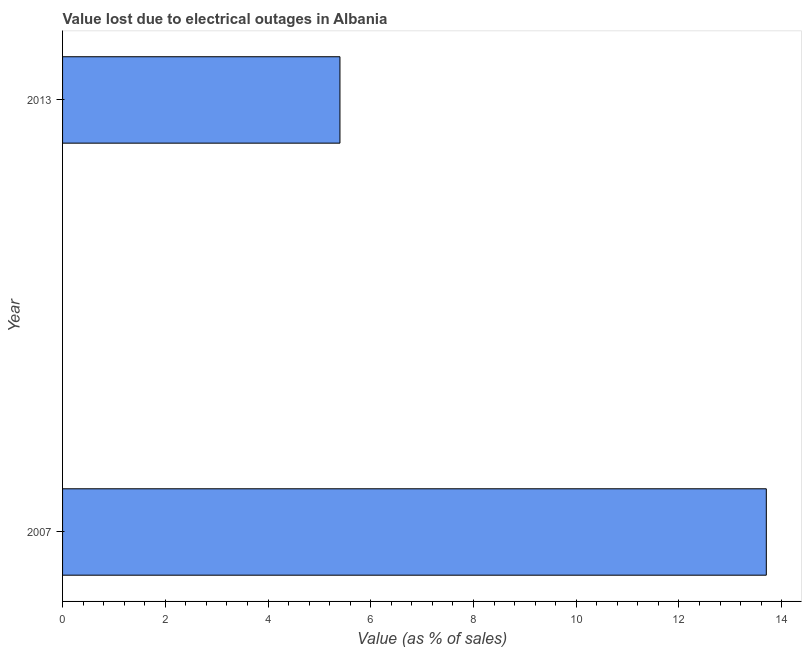Does the graph contain grids?
Offer a terse response. No. What is the title of the graph?
Make the answer very short. Value lost due to electrical outages in Albania. What is the label or title of the X-axis?
Provide a succinct answer. Value (as % of sales). What is the label or title of the Y-axis?
Your answer should be very brief. Year. Across all years, what is the minimum value lost due to electrical outages?
Provide a short and direct response. 5.4. In which year was the value lost due to electrical outages maximum?
Offer a terse response. 2007. In which year was the value lost due to electrical outages minimum?
Provide a short and direct response. 2013. What is the difference between the value lost due to electrical outages in 2007 and 2013?
Keep it short and to the point. 8.3. What is the average value lost due to electrical outages per year?
Make the answer very short. 9.55. What is the median value lost due to electrical outages?
Keep it short and to the point. 9.55. Do a majority of the years between 2007 and 2013 (inclusive) have value lost due to electrical outages greater than 6.4 %?
Your response must be concise. No. What is the ratio of the value lost due to electrical outages in 2007 to that in 2013?
Provide a succinct answer. 2.54. In how many years, is the value lost due to electrical outages greater than the average value lost due to electrical outages taken over all years?
Provide a short and direct response. 1. How many years are there in the graph?
Keep it short and to the point. 2. What is the Value (as % of sales) in 2013?
Offer a very short reply. 5.4. What is the difference between the Value (as % of sales) in 2007 and 2013?
Provide a short and direct response. 8.3. What is the ratio of the Value (as % of sales) in 2007 to that in 2013?
Give a very brief answer. 2.54. 